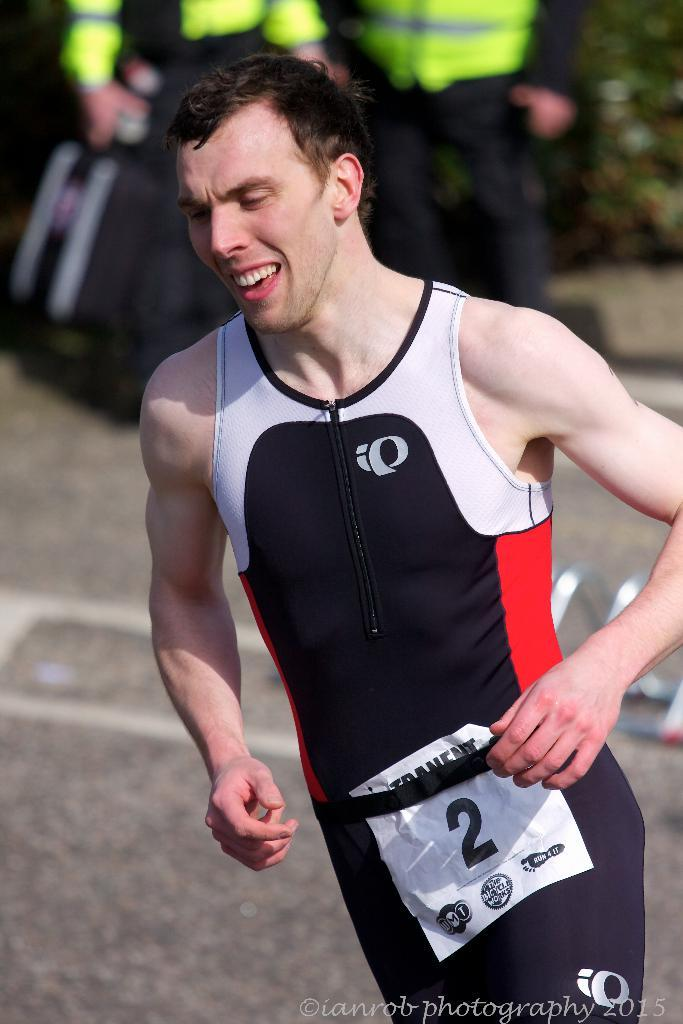<image>
Write a terse but informative summary of the picture. The runner in this race is wearing the number 2 bib. 